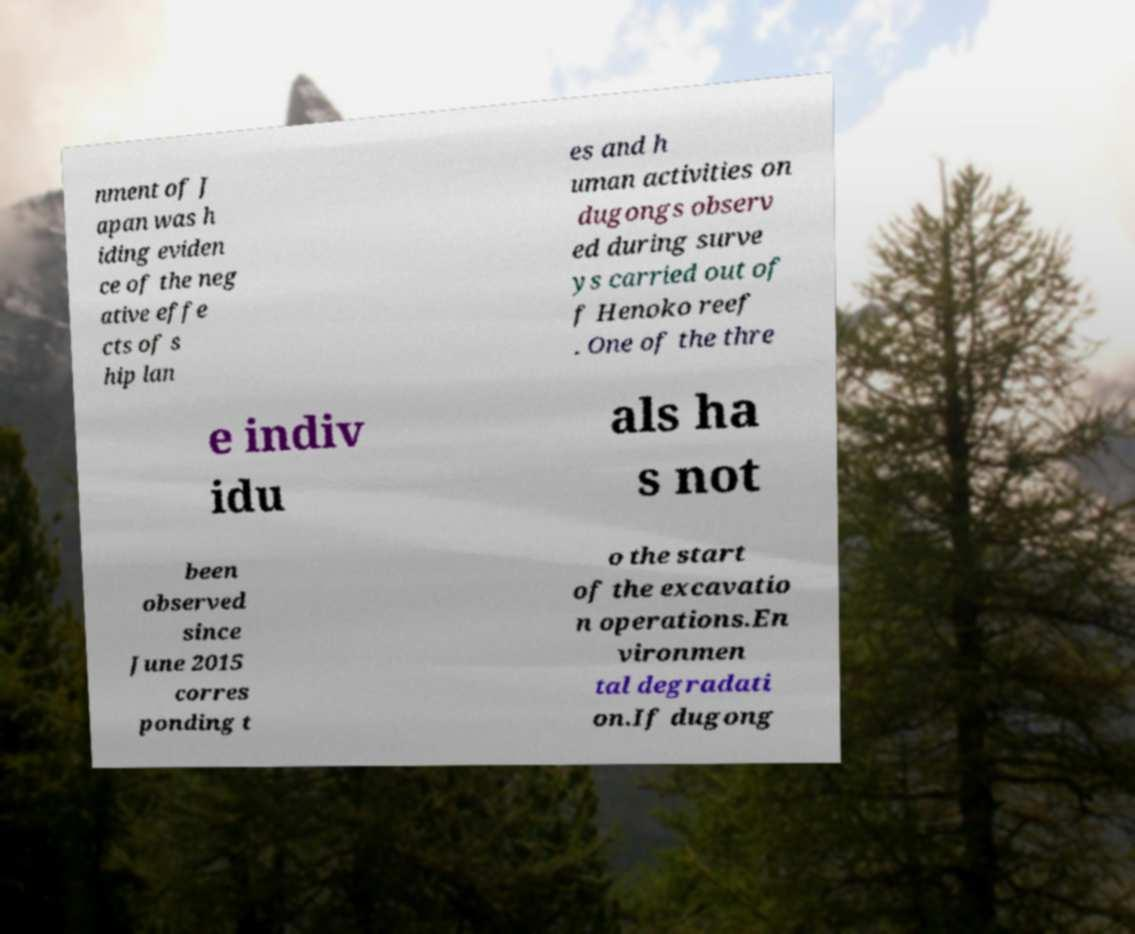Can you accurately transcribe the text from the provided image for me? nment of J apan was h iding eviden ce of the neg ative effe cts of s hip lan es and h uman activities on dugongs observ ed during surve ys carried out of f Henoko reef . One of the thre e indiv idu als ha s not been observed since June 2015 corres ponding t o the start of the excavatio n operations.En vironmen tal degradati on.If dugong 